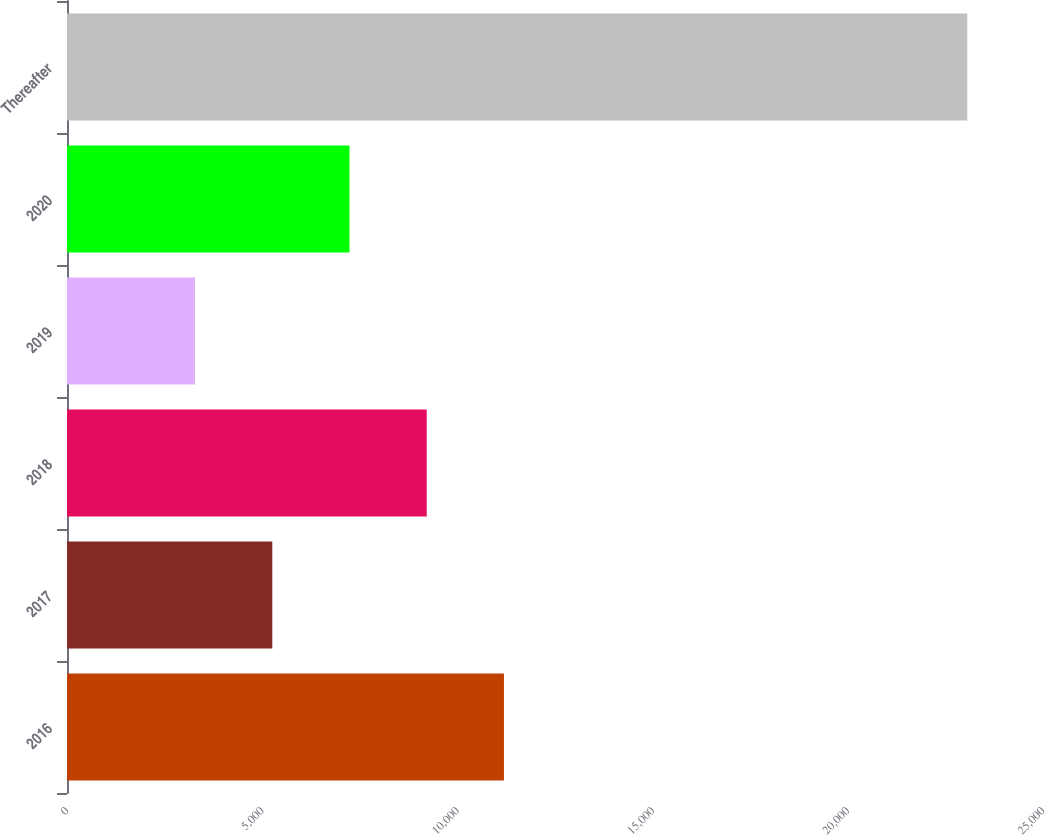Convert chart. <chart><loc_0><loc_0><loc_500><loc_500><bar_chart><fcel>2016<fcel>2017<fcel>2018<fcel>2019<fcel>2020<fcel>Thereafter<nl><fcel>11192.4<fcel>5258.1<fcel>9214.3<fcel>3280<fcel>7236.2<fcel>23061<nl></chart> 